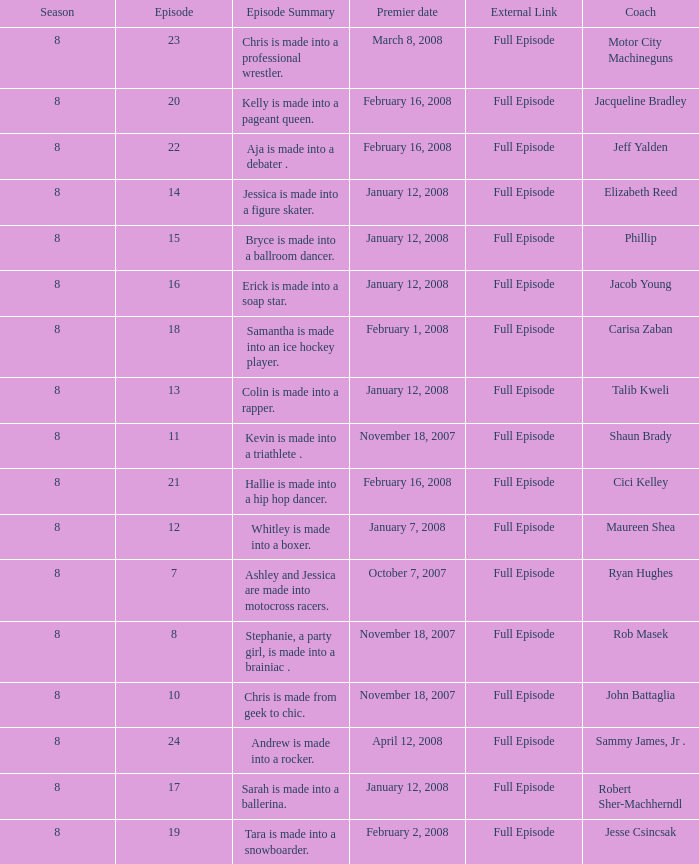Which Maximum episode premiered March 8, 2008? 23.0. 